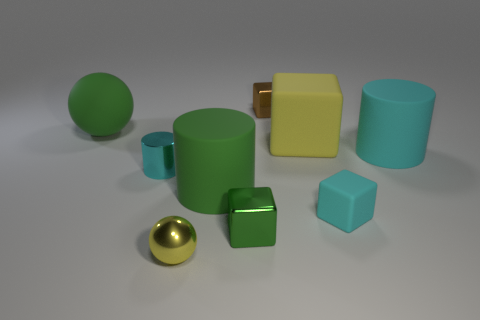What number of objects are small objects that are on the right side of the tiny green shiny thing or large things that are in front of the large green rubber ball?
Keep it short and to the point. 5. What is the color of the matte cube that is the same size as the green cylinder?
Provide a short and direct response. Yellow. Is the material of the tiny brown block the same as the tiny cyan cylinder?
Provide a succinct answer. Yes. What material is the tiny yellow sphere that is right of the tiny thing that is on the left side of the small metal ball made of?
Ensure brevity in your answer.  Metal. Are there more cyan objects that are on the left side of the large cyan object than cylinders?
Keep it short and to the point. No. How many other objects are there of the same size as the metal cylinder?
Your response must be concise. 4. Do the small cylinder and the metal ball have the same color?
Provide a succinct answer. No. What is the color of the tiny shiny thing behind the cyan rubber cylinder behind the ball in front of the big matte ball?
Offer a very short reply. Brown. How many big green cylinders are in front of the small metal cube that is in front of the object behind the green sphere?
Your answer should be compact. 0. Is there anything else that is the same color as the small metal cylinder?
Offer a terse response. Yes. 